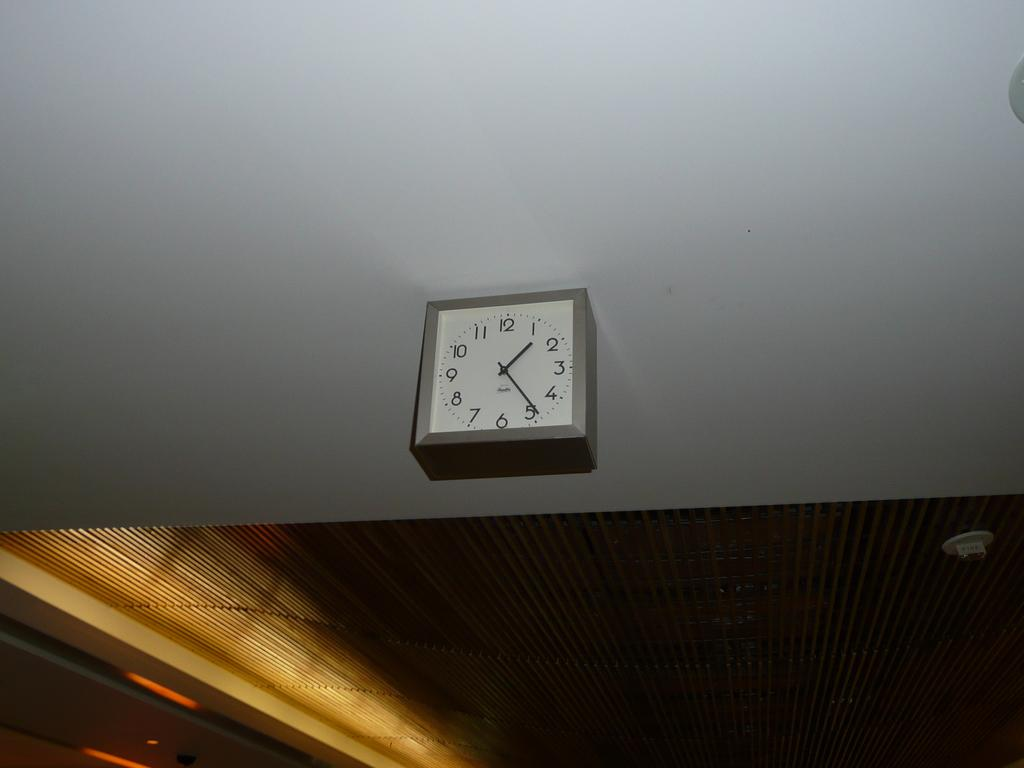<image>
Give a short and clear explanation of the subsequent image. A clock hanging from the ceiling telling the time 1:24. 